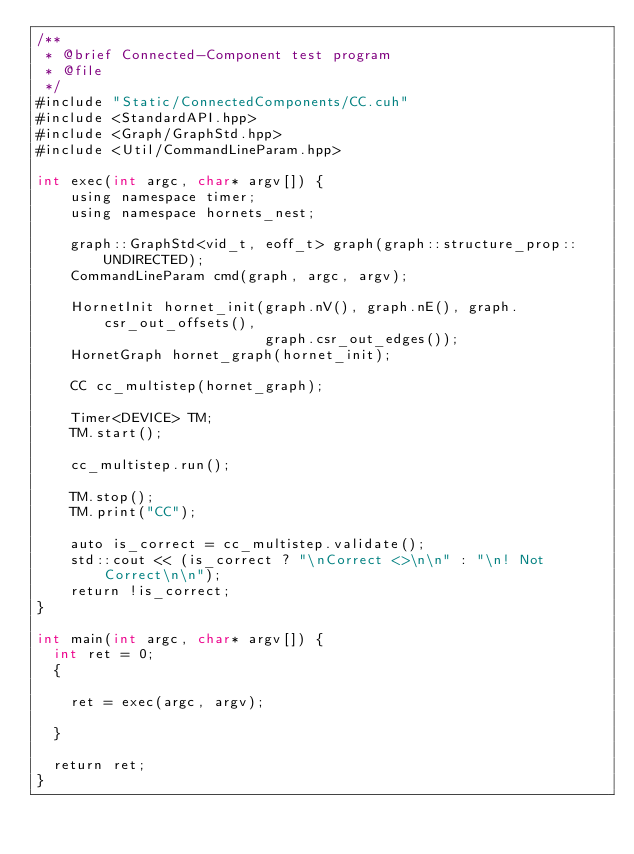Convert code to text. <code><loc_0><loc_0><loc_500><loc_500><_Cuda_>/**
 * @brief Connected-Component test program
 * @file
 */
#include "Static/ConnectedComponents/CC.cuh"
#include <StandardAPI.hpp>
#include <Graph/GraphStd.hpp>
#include <Util/CommandLineParam.hpp>

int exec(int argc, char* argv[]) {
    using namespace timer;
    using namespace hornets_nest;

    graph::GraphStd<vid_t, eoff_t> graph(graph::structure_prop::UNDIRECTED);
    CommandLineParam cmd(graph, argc, argv);

    HornetInit hornet_init(graph.nV(), graph.nE(), graph.csr_out_offsets(),
                           graph.csr_out_edges());
    HornetGraph hornet_graph(hornet_init);

    CC cc_multistep(hornet_graph);

    Timer<DEVICE> TM;
    TM.start();

    cc_multistep.run();

    TM.stop();
    TM.print("CC");

    auto is_correct = cc_multistep.validate();
    std::cout << (is_correct ? "\nCorrect <>\n\n" : "\n! Not Correct\n\n");
    return !is_correct;
}

int main(int argc, char* argv[]) {
  int ret = 0;
  {

    ret = exec(argc, argv);

  }

  return ret;
}
</code> 